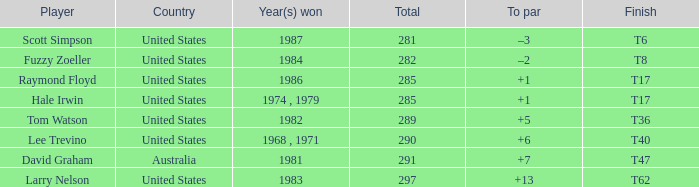What player has a total of 290 points? Lee Trevino. 